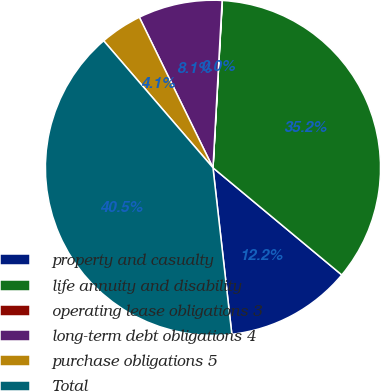Convert chart to OTSL. <chart><loc_0><loc_0><loc_500><loc_500><pie_chart><fcel>property and casualty<fcel>life annuity and disability<fcel>operating lease obligations 3<fcel>long-term debt obligations 4<fcel>purchase obligations 5<fcel>Total<nl><fcel>12.16%<fcel>35.15%<fcel>0.02%<fcel>8.11%<fcel>4.07%<fcel>40.48%<nl></chart> 